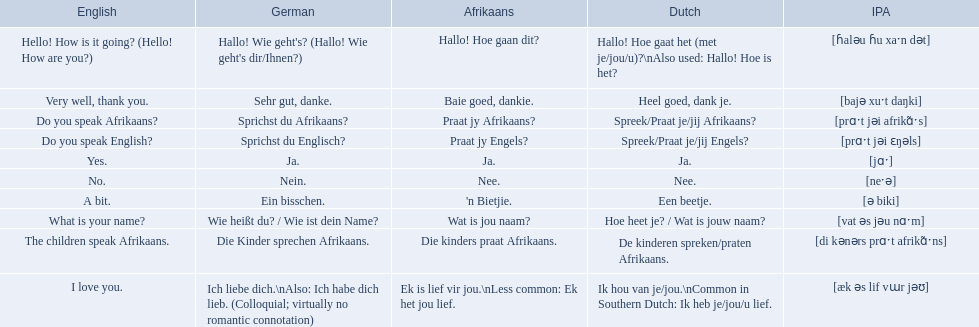What are the afrikaans phrases? Hallo! Hoe gaan dit?, Baie goed, dankie., Praat jy Afrikaans?, Praat jy Engels?, Ja., Nee., 'n Bietjie., Wat is jou naam?, Die kinders praat Afrikaans., Ek is lief vir jou.\nLess common: Ek het jou lief. For die kinders praat afrikaans, what are the translations? De kinderen spreken/praten Afrikaans., The children speak Afrikaans., Die Kinder sprechen Afrikaans. Which one is the german translation? Die Kinder sprechen Afrikaans. 